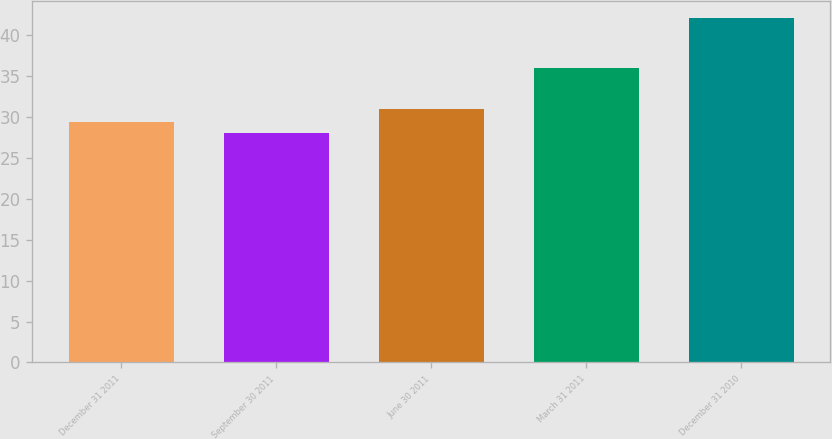Convert chart to OTSL. <chart><loc_0><loc_0><loc_500><loc_500><bar_chart><fcel>December 31 2011<fcel>September 30 2011<fcel>June 30 2011<fcel>March 31 2011<fcel>December 31 2010<nl><fcel>29.4<fcel>28<fcel>31<fcel>36<fcel>42<nl></chart> 